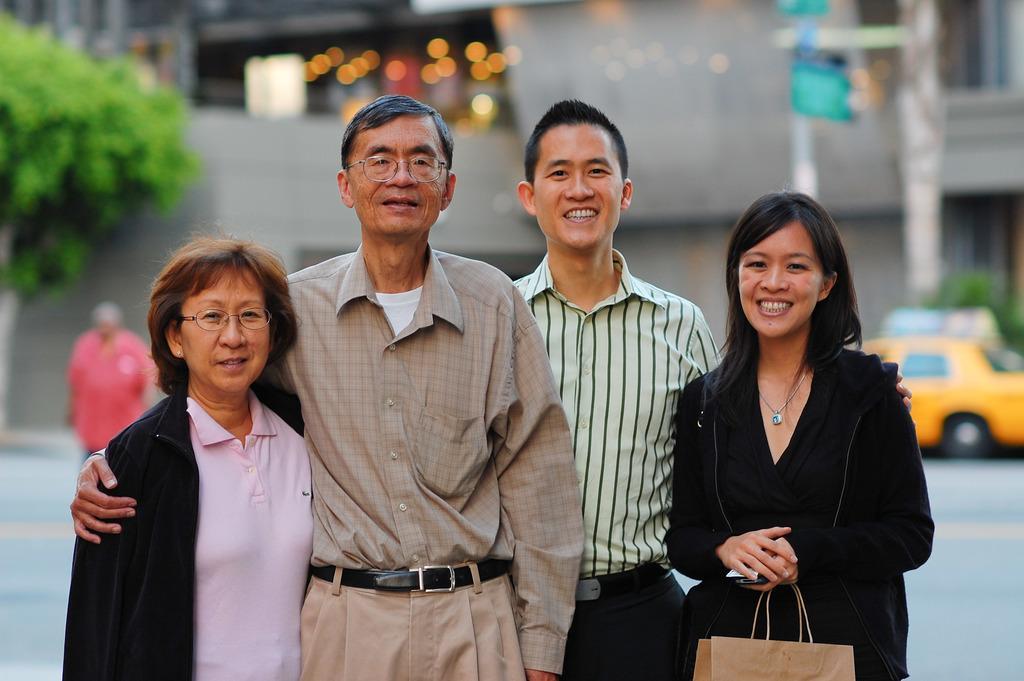How would you summarize this image in a sentence or two? There are two men and two women standing and smiling. This woman is holding a bag in her hands. This looks like a tree. I can see the buildings and lights. This is a car, which is parked. Here is a pole. I can see another person standing. 